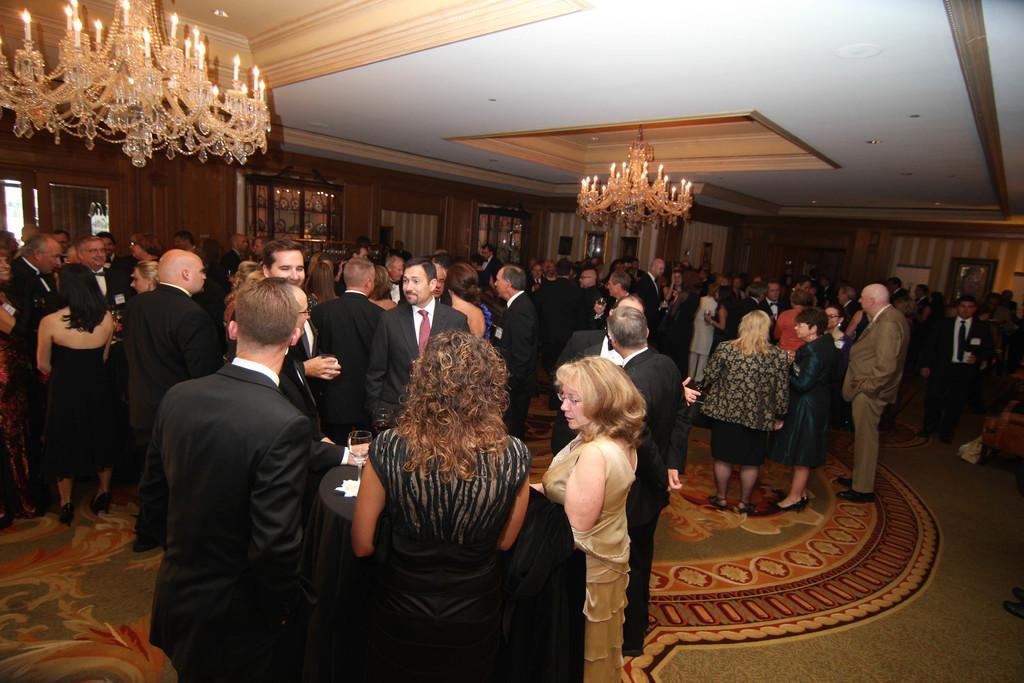How many people are in the image? There is a group of people in the image, but the exact number is not specified. What are the people in the image doing? The people are standing, and the scene appears to be a party. What can be seen at the top of the image? There are lights visible at the top of the image. What shape is the tray being used by the people in the image? There is no tray present in the image, so it is not possible to determine its shape. 